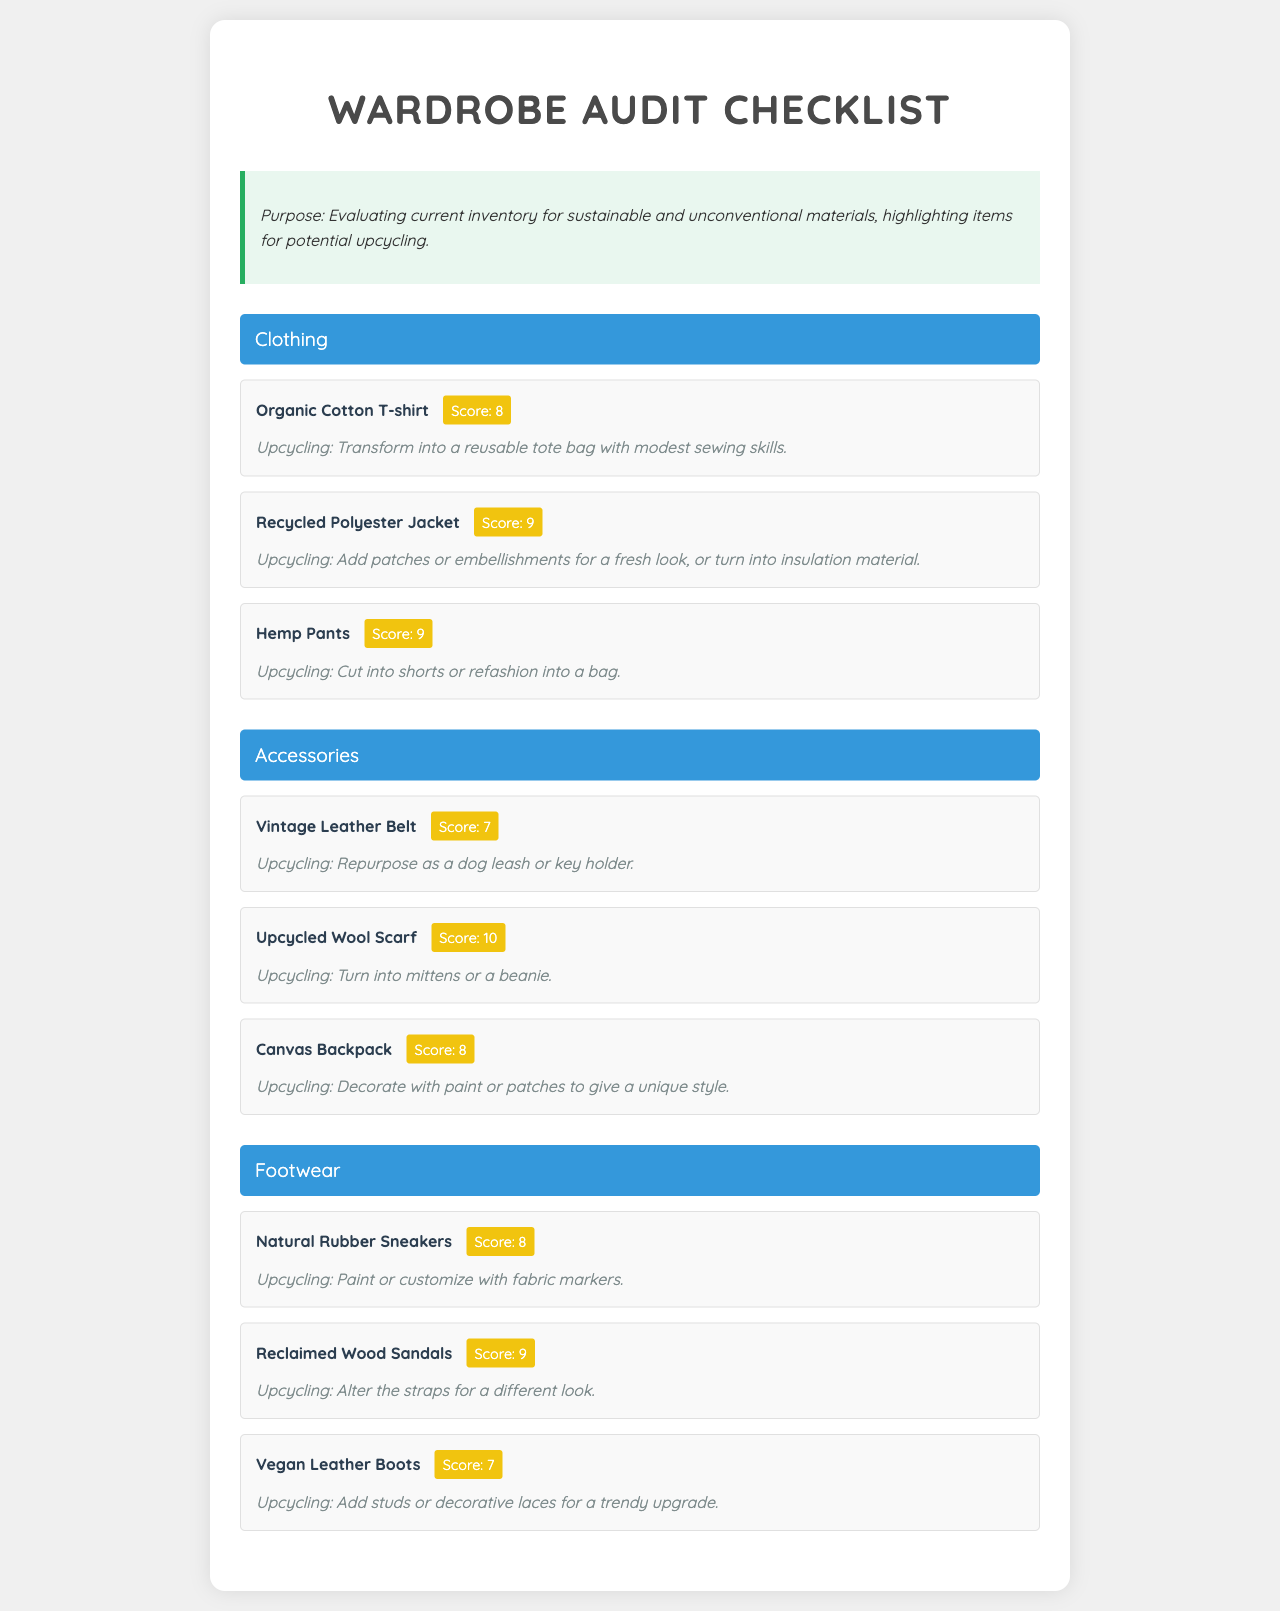What is the sustainability score of the Organic Cotton T-shirt? The sustainability score is specifically mentioned in the document for the Organic Cotton T-shirt as 8.
Answer: 8 What potential upcycling is suggested for the Vintage Leather Belt? The document states that the Vintage Leather Belt can be repurposed as a dog leash or key holder.
Answer: Dog leash or key holder Which material is the Upcycled Wool Scarf made from? The Upcycled Wool Scarf is explicitly mentioned as being made from upcycled wool in the document.
Answer: Upcycled wool What is the highest sustainability score among the items listed? The highest sustainability score is identified in the document as 10, assigned to the Upcycled Wool Scarf.
Answer: 10 How can the Hemp Pants be upcycled? The document suggests that the Hemp Pants can be cut into shorts or refashioned into a bag.
Answer: Cut into shorts or refashioned into a bag What type of footwear is the Natural Rubber Sneakers made from? The document indicates that the Natural Rubber Sneakers are crafted from natural rubber.
Answer: Natural rubber How many clothing items are listed in the audit? The document includes three clothing items presented under the Clothing category.
Answer: Three Which accessory has the highest sustainability score? According to the document, the Upcycled Wool Scarf has the highest sustainability score, which is 10.
Answer: Upcycled Wool Scarf What unique upcycling suggestion is given for the Canvas Backpack? The document mentions that the Canvas Backpack can be decorated with paint or patches to give a unique style.
Answer: Decorate with paint or patches 